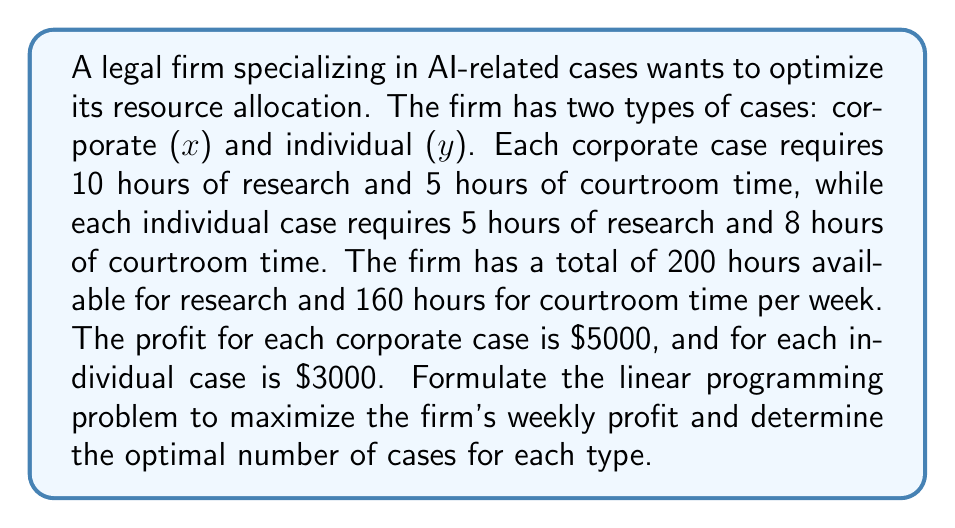Give your solution to this math problem. 1. Define the objective function:
   Maximize profit: $Z = 5000x + 3000y$

2. Identify constraints:
   Research time: $10x + 5y \leq 200$
   Courtroom time: $5x + 8y \leq 160$
   Non-negativity: $x \geq 0, y \geq 0$

3. Graph the constraints:
   [asy]
   import geometry;
   
   size(200);
   
   xaxis("x", 0, 40);
   yaxis("y", 0, 40);
   
   draw((0,40)--(20,0), blue);
   draw((0,20)--(32,0), red);
   
   label("10x + 5y = 200", (10,30), blue);
   label("5x + 8y = 160", (16,15), red);
   
   fill((0,0)--(20,0)--(16,10)--(0,20)--cycle, lightgray);
   
   dot((16,10));
   label("(16, 10)", (16,10), SE);
   [/asy]

4. Identify the feasible region (shaded area) and corner points.

5. Evaluate the objective function at corner points:
   (0,0): $Z = 0$
   (20,0): $Z = 100,000$
   (0,20): $Z = 60,000$
   (16,10): $Z = 110,000$

6. The optimal solution is at (16,10), representing 16 corporate cases and 10 individual cases per week.

7. Maximum weekly profit: $Z = 5000(16) + 3000(10) = 110,000$
Answer: 16 corporate cases, 10 individual cases; $110,000 weekly profit 